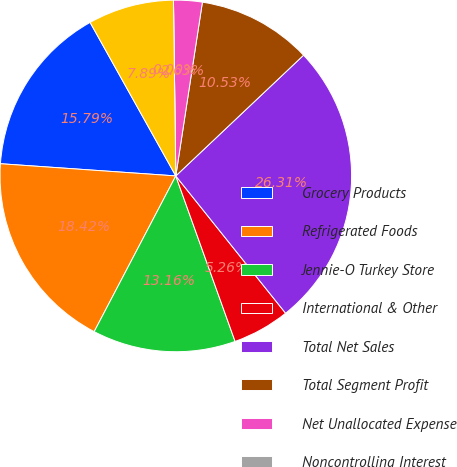Convert chart to OTSL. <chart><loc_0><loc_0><loc_500><loc_500><pie_chart><fcel>Grocery Products<fcel>Refrigerated Foods<fcel>Jennie-O Turkey Store<fcel>International & Other<fcel>Total Net Sales<fcel>Total Segment Profit<fcel>Net Unallocated Expense<fcel>Noncontrolling Interest<fcel>Earnings Before Income Taxes<nl><fcel>15.79%<fcel>18.42%<fcel>13.16%<fcel>5.26%<fcel>26.31%<fcel>10.53%<fcel>2.63%<fcel>0.0%<fcel>7.89%<nl></chart> 